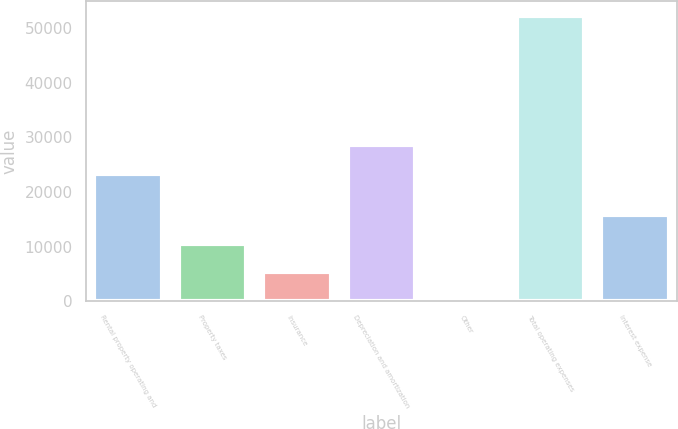Convert chart to OTSL. <chart><loc_0><loc_0><loc_500><loc_500><bar_chart><fcel>Rental property operating and<fcel>Property taxes<fcel>Insurance<fcel>Depreciation and amortization<fcel>Other<fcel>Total operating expenses<fcel>Interest expense<nl><fcel>23303<fcel>10541.8<fcel>5315.9<fcel>28528.9<fcel>90<fcel>52349<fcel>15767.7<nl></chart> 